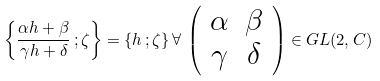<formula> <loc_0><loc_0><loc_500><loc_500>\left \{ \frac { \alpha h + \beta } { \gamma h + \delta } \, ; \zeta \right \} = \{ h \, ; \zeta \} \, \forall \, \left ( \begin{array} { c c } \alpha & \beta \\ \gamma & \delta \end{array} \right ) \in G L ( 2 , C )</formula> 